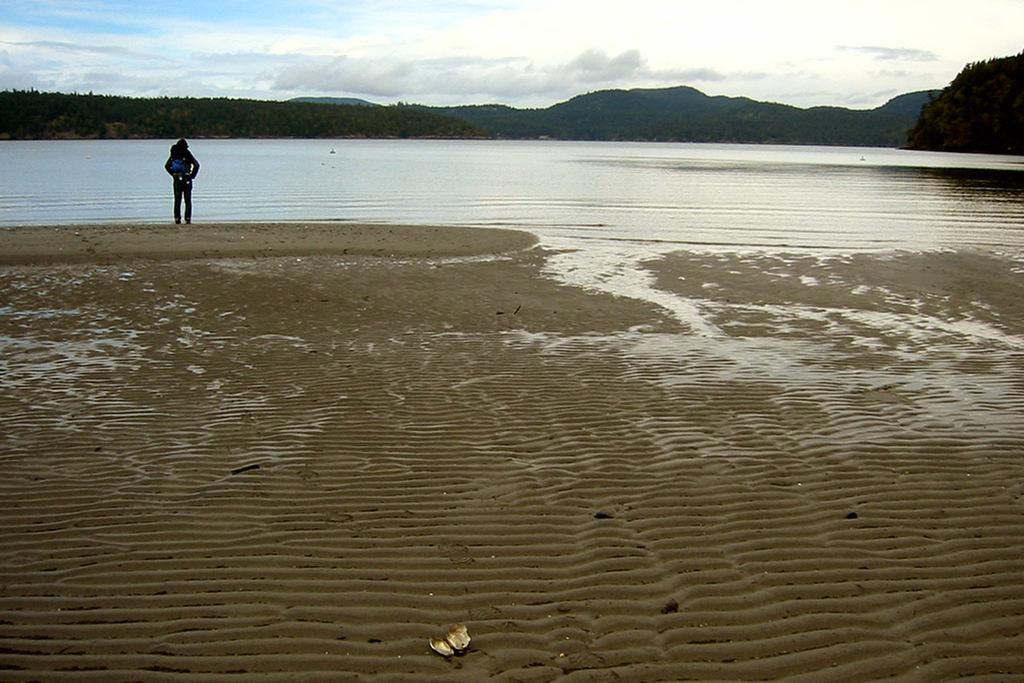What type of natural feature is present in the image? There is a river in the image. Can you describe the person's location in relation to the river? A person is standing on the river bank. What can be seen in the distance in the image? There are mountains and trees in the background of the image. What type of desk is visible in the image? There is no desk present in the image. How many passengers are in the image? There is no reference to passengers in the image; it features a person standing on the river bank. 